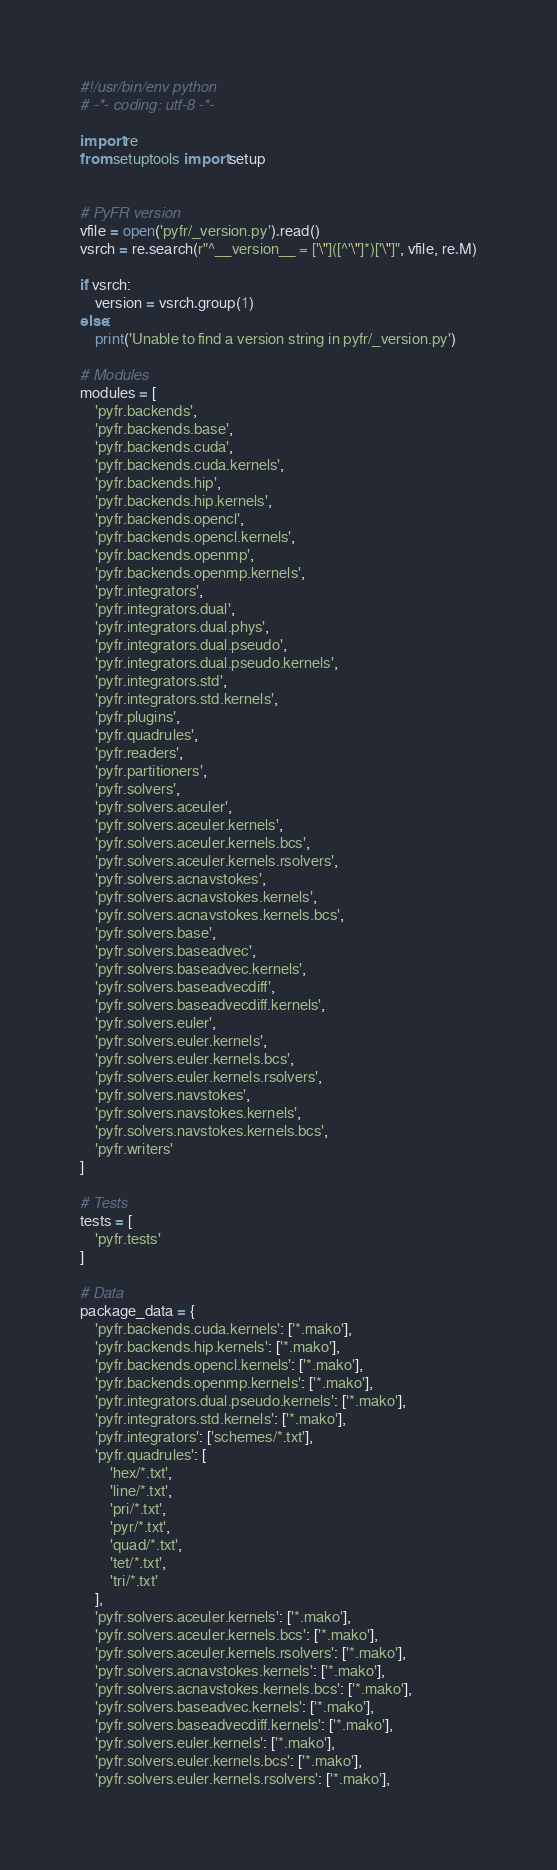<code> <loc_0><loc_0><loc_500><loc_500><_Python_>#!/usr/bin/env python
# -*- coding: utf-8 -*-

import re
from setuptools import setup


# PyFR version
vfile = open('pyfr/_version.py').read()
vsrch = re.search(r"^__version__ = ['\"]([^'\"]*)['\"]", vfile, re.M)

if vsrch:
    version = vsrch.group(1)
else:
    print('Unable to find a version string in pyfr/_version.py')

# Modules
modules = [
    'pyfr.backends',
    'pyfr.backends.base',
    'pyfr.backends.cuda',
    'pyfr.backends.cuda.kernels',
    'pyfr.backends.hip',
    'pyfr.backends.hip.kernels',
    'pyfr.backends.opencl',
    'pyfr.backends.opencl.kernels',
    'pyfr.backends.openmp',
    'pyfr.backends.openmp.kernels',
    'pyfr.integrators',
    'pyfr.integrators.dual',
    'pyfr.integrators.dual.phys',
    'pyfr.integrators.dual.pseudo',
    'pyfr.integrators.dual.pseudo.kernels',
    'pyfr.integrators.std',
    'pyfr.integrators.std.kernels',
    'pyfr.plugins',
    'pyfr.quadrules',
    'pyfr.readers',
    'pyfr.partitioners',
    'pyfr.solvers',
    'pyfr.solvers.aceuler',
    'pyfr.solvers.aceuler.kernels',
    'pyfr.solvers.aceuler.kernels.bcs',
    'pyfr.solvers.aceuler.kernels.rsolvers',
    'pyfr.solvers.acnavstokes',
    'pyfr.solvers.acnavstokes.kernels',
    'pyfr.solvers.acnavstokes.kernels.bcs',
    'pyfr.solvers.base',
    'pyfr.solvers.baseadvec',
    'pyfr.solvers.baseadvec.kernels',
    'pyfr.solvers.baseadvecdiff',
    'pyfr.solvers.baseadvecdiff.kernels',
    'pyfr.solvers.euler',
    'pyfr.solvers.euler.kernels',
    'pyfr.solvers.euler.kernels.bcs',
    'pyfr.solvers.euler.kernels.rsolvers',
    'pyfr.solvers.navstokes',
    'pyfr.solvers.navstokes.kernels',
    'pyfr.solvers.navstokes.kernels.bcs',
    'pyfr.writers'
]

# Tests
tests = [
    'pyfr.tests'
]

# Data
package_data = {
    'pyfr.backends.cuda.kernels': ['*.mako'],
    'pyfr.backends.hip.kernels': ['*.mako'],
    'pyfr.backends.opencl.kernels': ['*.mako'],
    'pyfr.backends.openmp.kernels': ['*.mako'],
    'pyfr.integrators.dual.pseudo.kernels': ['*.mako'],
    'pyfr.integrators.std.kernels': ['*.mako'],
    'pyfr.integrators': ['schemes/*.txt'],
    'pyfr.quadrules': [
        'hex/*.txt',
        'line/*.txt',
        'pri/*.txt',
        'pyr/*.txt',
        'quad/*.txt',
        'tet/*.txt',
        'tri/*.txt'
    ],
    'pyfr.solvers.aceuler.kernels': ['*.mako'],
    'pyfr.solvers.aceuler.kernels.bcs': ['*.mako'],
    'pyfr.solvers.aceuler.kernels.rsolvers': ['*.mako'],
    'pyfr.solvers.acnavstokes.kernels': ['*.mako'],
    'pyfr.solvers.acnavstokes.kernels.bcs': ['*.mako'],
    'pyfr.solvers.baseadvec.kernels': ['*.mako'],
    'pyfr.solvers.baseadvecdiff.kernels': ['*.mako'],
    'pyfr.solvers.euler.kernels': ['*.mako'],
    'pyfr.solvers.euler.kernels.bcs': ['*.mako'],
    'pyfr.solvers.euler.kernels.rsolvers': ['*.mako'],</code> 